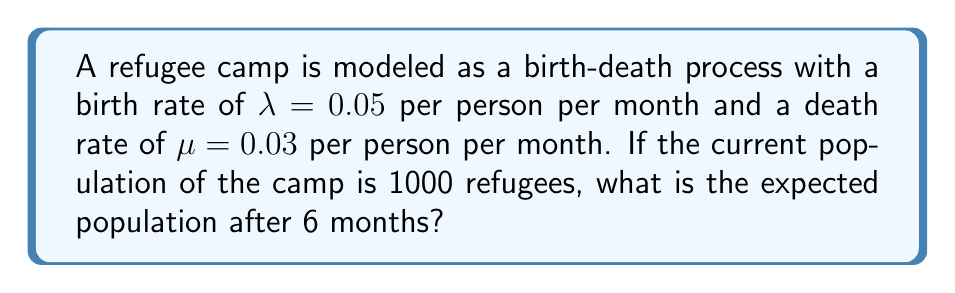Teach me how to tackle this problem. To solve this problem, we'll use the birth-death process model and follow these steps:

1) In a birth-death process, the expected population size at time $t$, given an initial population of $N_0$, is:

   $$E[N(t)] = N_0 e^{(\lambda - \mu)t}$$

2) We're given:
   - Initial population $N_0 = 1000$
   - Birth rate $\lambda = 0.05$ per person per month
   - Death rate $\mu = 0.03$ per person per month
   - Time $t = 6$ months

3) Calculate $\lambda - \mu$:
   $$\lambda - \mu = 0.05 - 0.03 = 0.02$$

4) Now, let's substitute these values into our equation:

   $$E[N(6)] = 1000 e^{(0.02)(6)}$$

5) Simplify:
   $$E[N(6)] = 1000 e^{0.12}$$

6) Calculate $e^{0.12}$ (you can use a calculator for this):
   $$e^{0.12} \approx 1.1275$$

7) Multiply:
   $$E[N(6)] = 1000 \times 1.1275 = 1127.5$$

8) Since we're dealing with people, we round to the nearest whole number:
   $$E[N(6)] \approx 1128$$

Therefore, the expected population after 6 months is approximately 1128 refugees.
Answer: 1128 refugees 